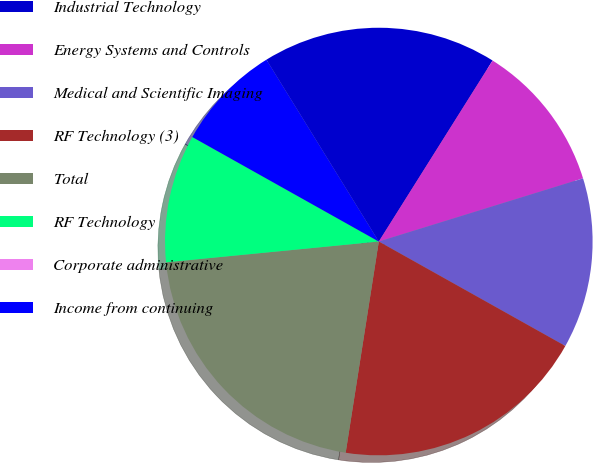Convert chart to OTSL. <chart><loc_0><loc_0><loc_500><loc_500><pie_chart><fcel>Industrial Technology<fcel>Energy Systems and Controls<fcel>Medical and Scientific Imaging<fcel>RF Technology (3)<fcel>Total<fcel>RF Technology<fcel>Corporate administrative<fcel>Income from continuing<nl><fcel>17.74%<fcel>11.29%<fcel>12.9%<fcel>19.35%<fcel>20.97%<fcel>9.68%<fcel>0.0%<fcel>8.06%<nl></chart> 